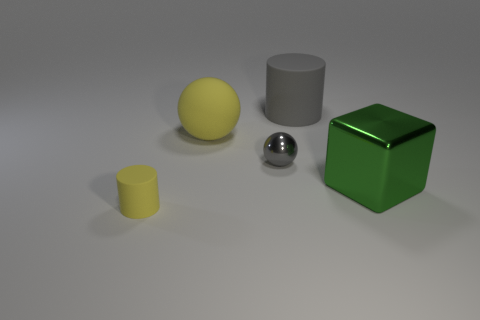Add 2 tiny gray shiny objects. How many objects exist? 7 Subtract all cylinders. How many objects are left? 3 Subtract all yellow balls. Subtract all large cyan metal cylinders. How many objects are left? 4 Add 5 yellow matte balls. How many yellow matte balls are left? 6 Add 5 gray matte cylinders. How many gray matte cylinders exist? 6 Subtract 1 gray cylinders. How many objects are left? 4 